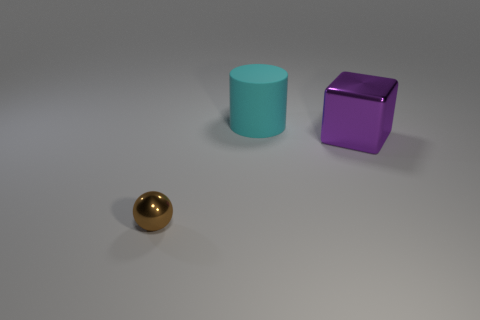What material is the thing that is in front of the cyan cylinder and on the right side of the brown object?
Give a very brief answer. Metal. How many large things are brown metallic objects or purple things?
Keep it short and to the point. 1. What size is the metal sphere?
Provide a short and direct response. Small. The cyan thing is what shape?
Your response must be concise. Cylinder. Is there any other thing that is the same shape as the big cyan rubber object?
Offer a terse response. No. Is the number of large matte cylinders that are on the left side of the big cyan thing less than the number of cylinders?
Offer a terse response. Yes. There is a tiny shiny sphere in front of the metal cube; does it have the same color as the rubber object?
Offer a very short reply. No. What number of rubber objects are cyan objects or gray cubes?
Your answer should be compact. 1. Is there anything else that has the same size as the rubber cylinder?
Offer a terse response. Yes. The big block that is made of the same material as the ball is what color?
Ensure brevity in your answer.  Purple. 